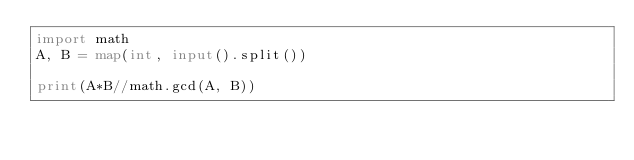Convert code to text. <code><loc_0><loc_0><loc_500><loc_500><_Python_>import math
A, B = map(int, input().split())

print(A*B//math.gcd(A, B))</code> 